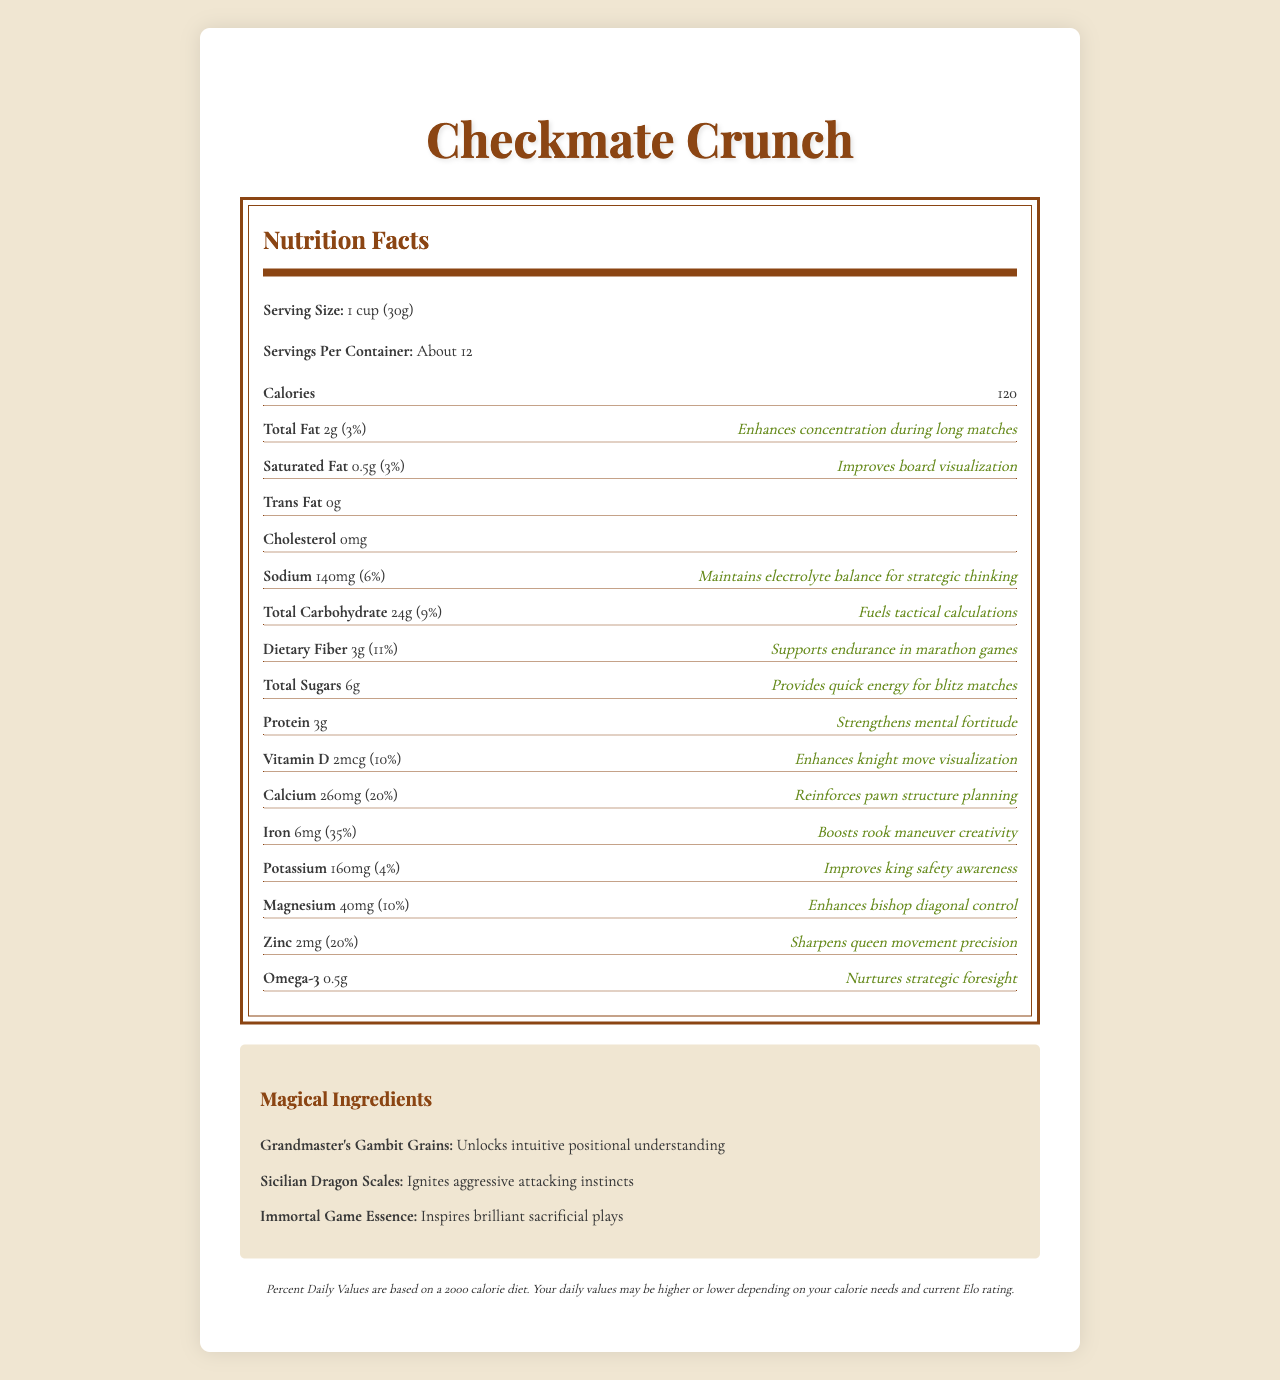what is the serving size of Checkmate Crunch? The serving size is clearly stated as "1 cup (30g)" in the Nutrition Facts label.
Answer: 1 cup (30g) how many calories are in one serving of Checkmate Crunch? The label specifies that each serving contains 120 calories.
Answer: 120 calories which component of Checkmate Crunch is said to enhance concentration during long matches? The description for total fat mentions that it "Enhances concentration during long matches".
Answer: Total Fat how much dietary fiber does Checkmate Crunch contain per serving? The label states that each serving contains 3 grams of dietary fiber.
Answer: 3g what percentage of the daily value of magnesium is in one serving of Checkmate Crunch? The label indicates that one serving contains 10% of the daily value of magnesium.
Answer: 10% which ingredient in Checkmate Crunch is said to ignite aggressive attacking instincts? A. Grandmaster's Gambit Grains B. Sicilian Dragon Scales C. Immortal Game Essence D. Knight's Honor Flakes The description under "Magical Ingredients" mentions that Sicilian Dragon Scales "Ignites aggressive attacking instincts".
Answer: B. Sicilian Dragon Scales which nutrient in Checkmate Crunch supports endurance in long games? A. Calcium B. Fiber C. Omega-3 D. Iron The description for dietary fiber says it "Supports endurance in marathon games".
Answer: B. Fiber does Checkmate Crunch contain any trans fat? The label lists trans fat content as "0g".
Answer: No does one serving of Checkmate Crunch provide 10% of the daily value of vitamin D? The label specifies that one serving contains 10% of the daily value of vitamin D.
Answer: Yes summarize the nutritional benefits of Checkmate Crunch in one paragraph. This paragraph encapsulates the main nutritional and magical benefits of Checkmate Crunch, detailing how its various components benefit chess players.
Answer: Checkmate Crunch is a cereal designed to boost various aspects of chess play. Each serving (1 cup or 30g) contains 120 calories and an array of nutrients that enhance different skills such as concentration, board visualization, and strategic thinking. It has 2g of total fat for improved concentration, 0.5g of saturated fat for better board visualization, 140mg of sodium to maintain electrolytes for strategic thinking, 24g of carbohydrates for tactical calculations, and 3g of dietary fiber for endurance in long games. The cereal also includes 6g of sugars for quick energy, 3g of protein for mental fortitude, and various vitamins and minerals like vitamin D, calcium, iron, potassium, magnesium, and zinc which aid in different chess strategies. Additionally, it contains magical ingredients such as Grandmaster's Gambit Grains, Sicilian Dragon Scales, and Immortal Game Essence to further unlock chess skills. what is the specific description for the Omega-3 content in Checkmate Crunch? The label describes Omega-3 as "Nurturing strategic foresight".
Answer: Nurtures strategic foresight is it possible to determine the current Elo rating of the person consuming Checkmate Crunch from the label? The label does not provide any information about the current Elo rating of the consumer.
Answer: No 